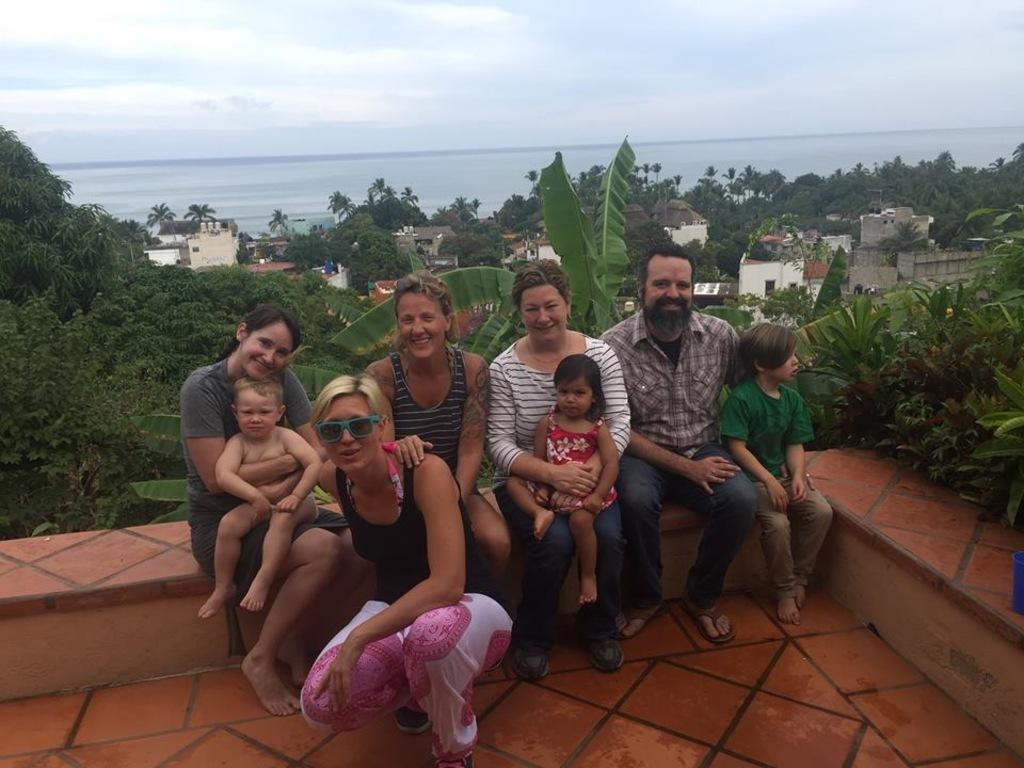What are the people in the image doing? There are many persons sitting on the wall in the center of the image. What can be seen in the background of the image? There are buildings, trees, water, and sky visible in the background of the image. What is the condition of the sky in the image? There are clouds in the sky. What type of button can be seen on the judge's hand in the image? There is no judge or button present in the image. What type of hand gesture is the person on the left making in the image? The provided facts do not mention any specific hand gestures made by the people in the image. 